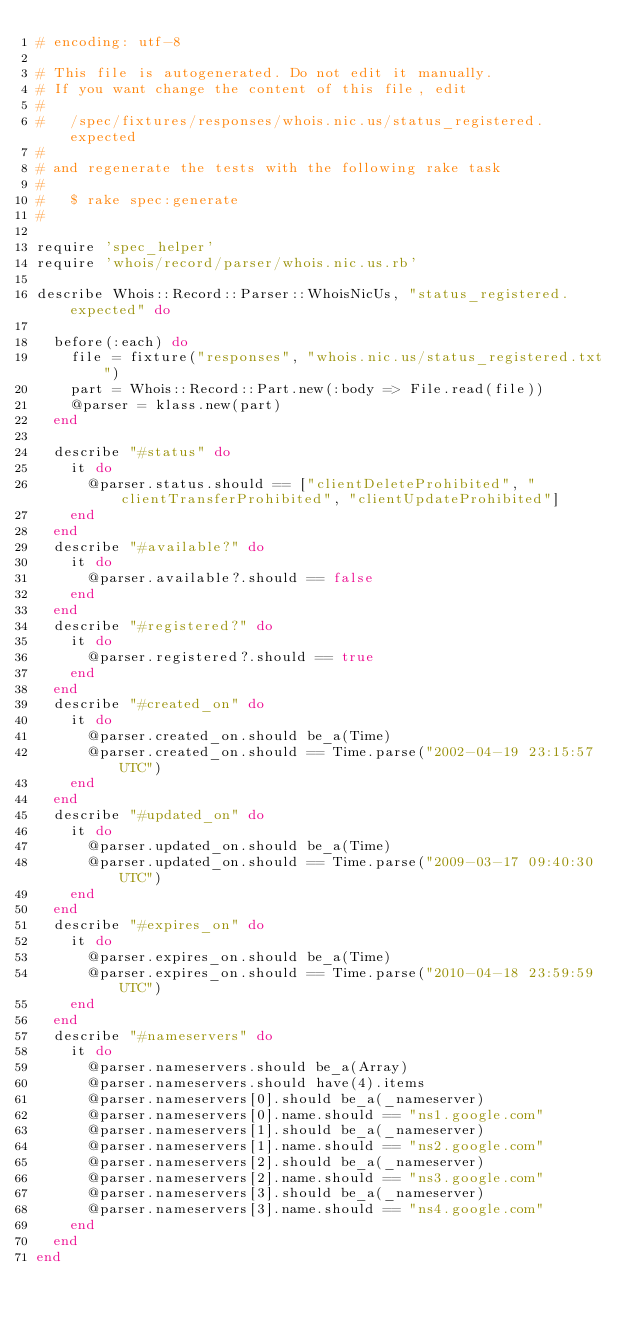<code> <loc_0><loc_0><loc_500><loc_500><_Ruby_># encoding: utf-8

# This file is autogenerated. Do not edit it manually.
# If you want change the content of this file, edit
#
#   /spec/fixtures/responses/whois.nic.us/status_registered.expected
#
# and regenerate the tests with the following rake task
#
#   $ rake spec:generate
#

require 'spec_helper'
require 'whois/record/parser/whois.nic.us.rb'

describe Whois::Record::Parser::WhoisNicUs, "status_registered.expected" do

  before(:each) do
    file = fixture("responses", "whois.nic.us/status_registered.txt")
    part = Whois::Record::Part.new(:body => File.read(file))
    @parser = klass.new(part)
  end

  describe "#status" do
    it do
      @parser.status.should == ["clientDeleteProhibited", "clientTransferProhibited", "clientUpdateProhibited"]
    end
  end
  describe "#available?" do
    it do
      @parser.available?.should == false
    end
  end
  describe "#registered?" do
    it do
      @parser.registered?.should == true
    end
  end
  describe "#created_on" do
    it do
      @parser.created_on.should be_a(Time)
      @parser.created_on.should == Time.parse("2002-04-19 23:15:57 UTC")
    end
  end
  describe "#updated_on" do
    it do
      @parser.updated_on.should be_a(Time)
      @parser.updated_on.should == Time.parse("2009-03-17 09:40:30 UTC")
    end
  end
  describe "#expires_on" do
    it do
      @parser.expires_on.should be_a(Time)
      @parser.expires_on.should == Time.parse("2010-04-18 23:59:59 UTC")
    end
  end
  describe "#nameservers" do
    it do
      @parser.nameservers.should be_a(Array)
      @parser.nameservers.should have(4).items
      @parser.nameservers[0].should be_a(_nameserver)
      @parser.nameservers[0].name.should == "ns1.google.com"
      @parser.nameservers[1].should be_a(_nameserver)
      @parser.nameservers[1].name.should == "ns2.google.com"
      @parser.nameservers[2].should be_a(_nameserver)
      @parser.nameservers[2].name.should == "ns3.google.com"
      @parser.nameservers[3].should be_a(_nameserver)
      @parser.nameservers[3].name.should == "ns4.google.com"
    end
  end
end
</code> 